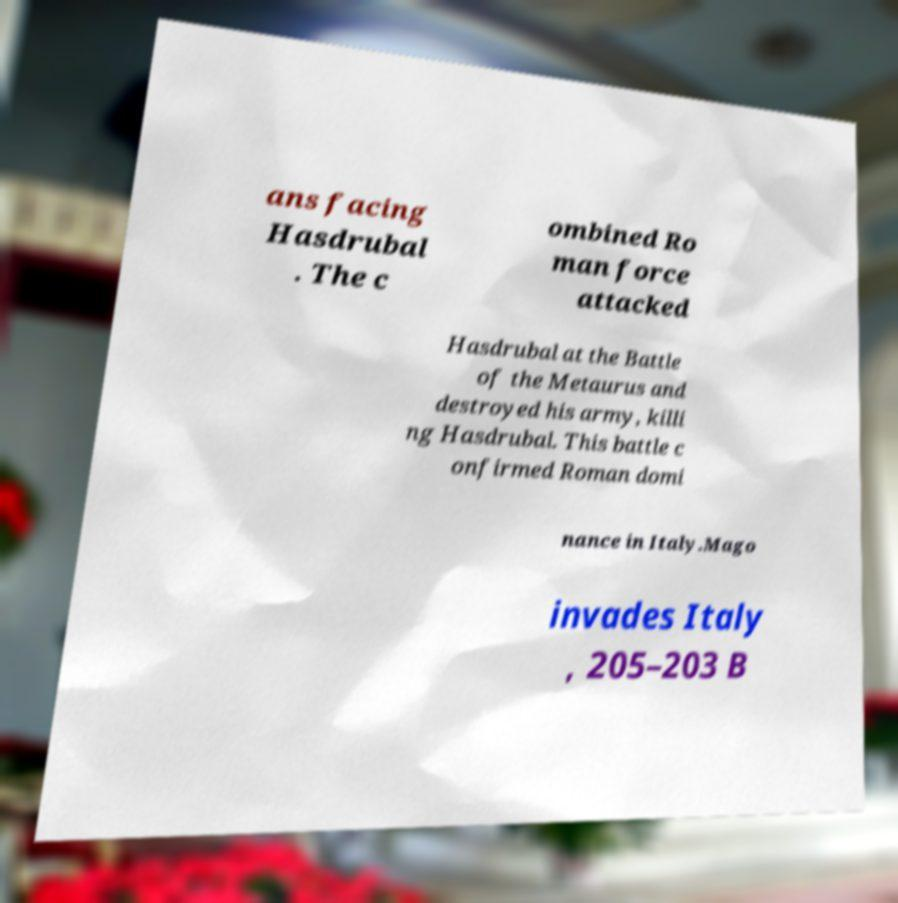There's text embedded in this image that I need extracted. Can you transcribe it verbatim? ans facing Hasdrubal . The c ombined Ro man force attacked Hasdrubal at the Battle of the Metaurus and destroyed his army, killi ng Hasdrubal. This battle c onfirmed Roman domi nance in Italy.Mago invades Italy , 205–203 B 